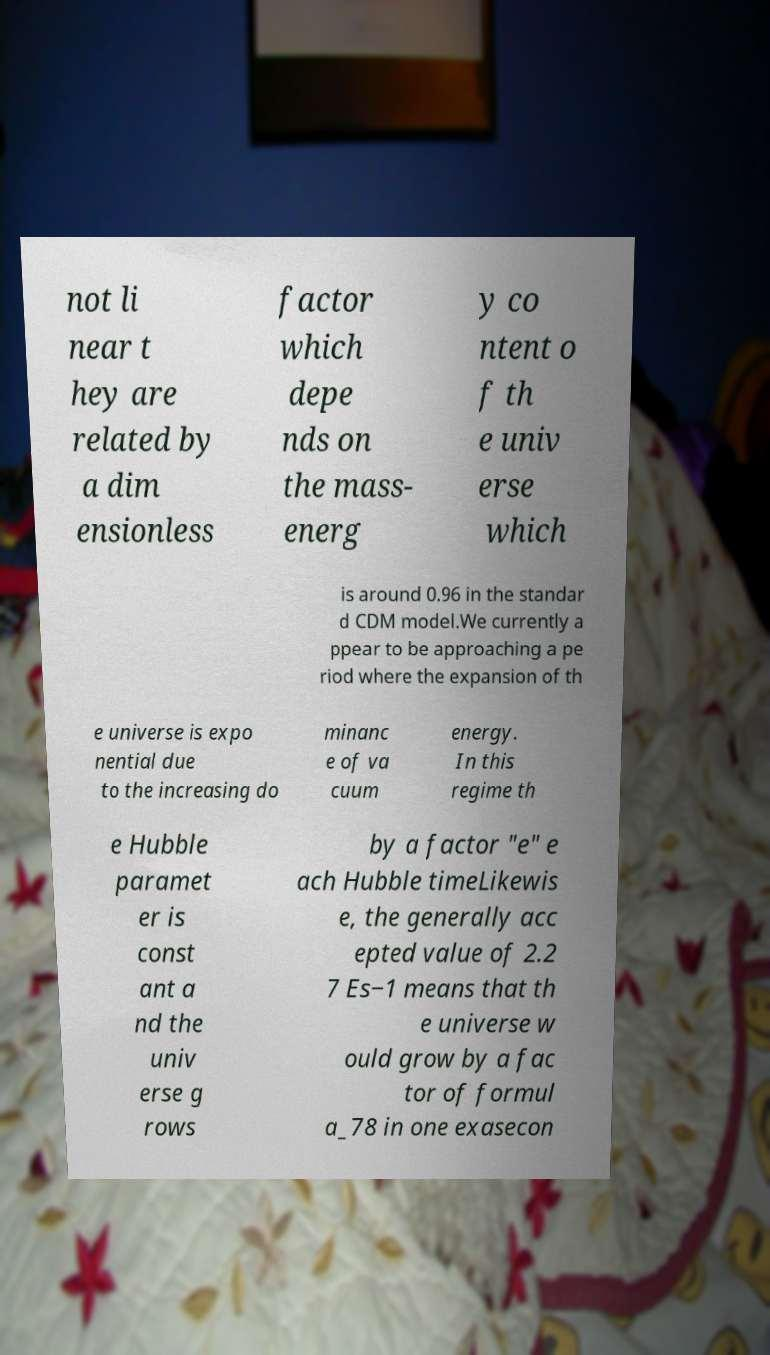Can you read and provide the text displayed in the image?This photo seems to have some interesting text. Can you extract and type it out for me? not li near t hey are related by a dim ensionless factor which depe nds on the mass- energ y co ntent o f th e univ erse which is around 0.96 in the standar d CDM model.We currently a ppear to be approaching a pe riod where the expansion of th e universe is expo nential due to the increasing do minanc e of va cuum energy. In this regime th e Hubble paramet er is const ant a nd the univ erse g rows by a factor "e" e ach Hubble timeLikewis e, the generally acc epted value of 2.2 7 Es−1 means that th e universe w ould grow by a fac tor of formul a_78 in one exasecon 